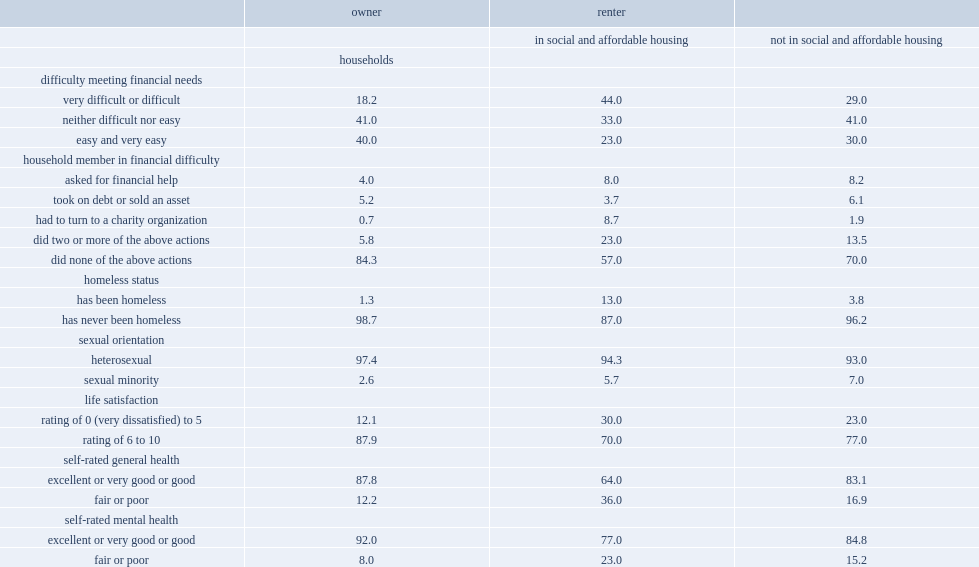What percent of reference persons of households in social and affordable housing reported being satisfied with their life. 70.0. What percent of reference persons of households living in social and affordable housing reported having experienced homelessness in the past. 13.0. What percent of reference persons living in social and affordable housing reported being in excellent, very good or good general health? 64.0. What percent of owners reported being satisfied with their life? 87.9. What percent of reference persons of households living in social and affordable housing reported having experienced homelessness in the past? 13.0. What percent of reference persons of renter households not in social and affordable housing have been homeless? 3.8. 